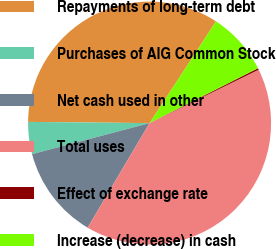<chart> <loc_0><loc_0><loc_500><loc_500><pie_chart><fcel>Repayments of long-term debt<fcel>Purchases of AIG Common Stock<fcel>Net cash used in other<fcel>Total uses<fcel>Effect of exchange rate<fcel>Increase (decrease) in cash<nl><fcel>34.05%<fcel>4.27%<fcel>12.38%<fcel>40.75%<fcel>0.22%<fcel>8.33%<nl></chart> 